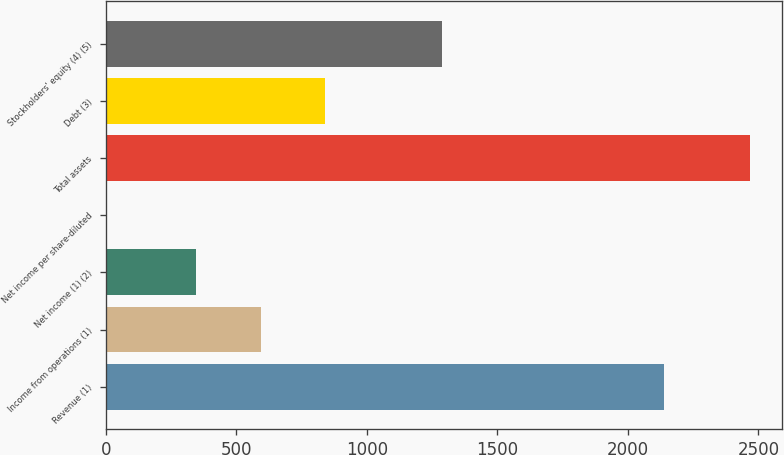<chart> <loc_0><loc_0><loc_500><loc_500><bar_chart><fcel>Revenue (1)<fcel>Income from operations (1)<fcel>Net income (1) (2)<fcel>Net income per share-diluted<fcel>Total assets<fcel>Debt (3)<fcel>Stockholders' equity (4) (5)<nl><fcel>2138<fcel>592.55<fcel>345.8<fcel>1.23<fcel>2468.7<fcel>839.3<fcel>1288.4<nl></chart> 